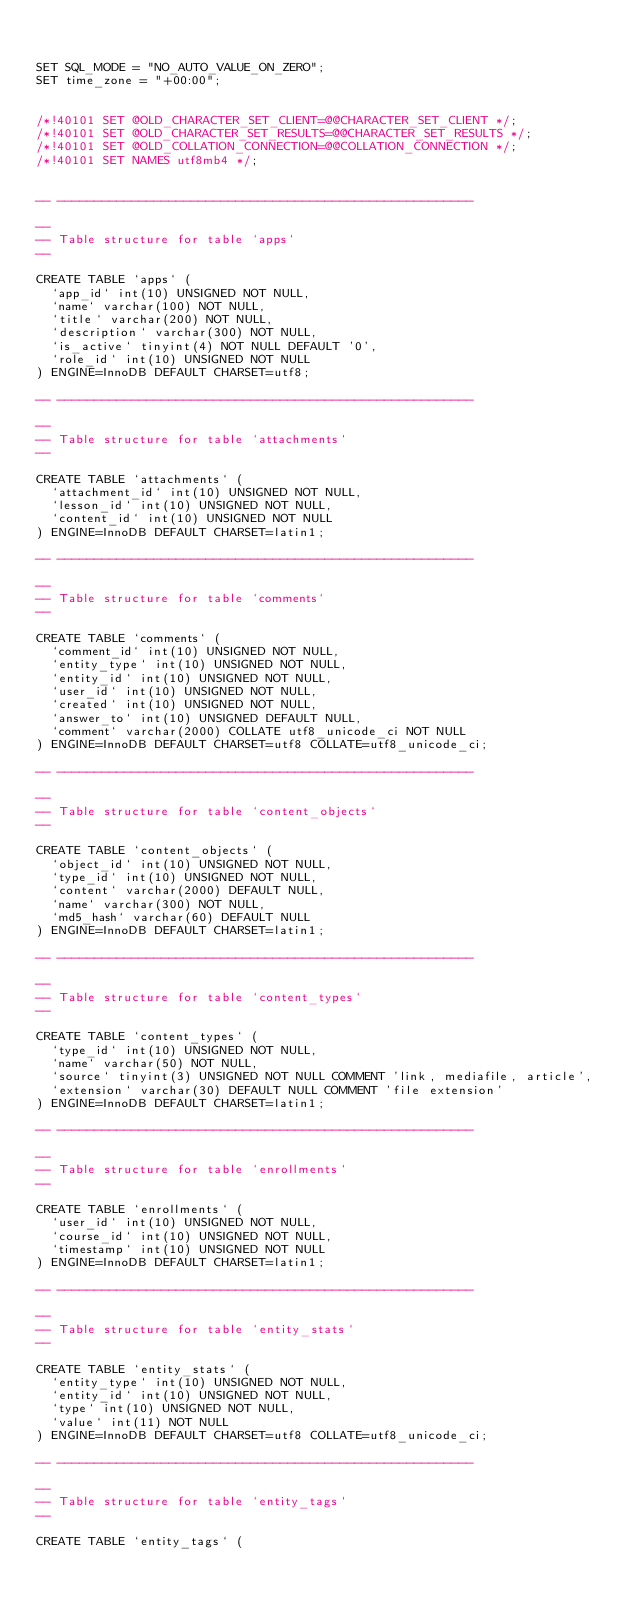Convert code to text. <code><loc_0><loc_0><loc_500><loc_500><_SQL_>

SET SQL_MODE = "NO_AUTO_VALUE_ON_ZERO";
SET time_zone = "+00:00";


/*!40101 SET @OLD_CHARACTER_SET_CLIENT=@@CHARACTER_SET_CLIENT */;
/*!40101 SET @OLD_CHARACTER_SET_RESULTS=@@CHARACTER_SET_RESULTS */;
/*!40101 SET @OLD_COLLATION_CONNECTION=@@COLLATION_CONNECTION */;
/*!40101 SET NAMES utf8mb4 */;


-- --------------------------------------------------------

--
-- Table structure for table `apps`
--

CREATE TABLE `apps` (
  `app_id` int(10) UNSIGNED NOT NULL,
  `name` varchar(100) NOT NULL,
  `title` varchar(200) NOT NULL,
  `description` varchar(300) NOT NULL,
  `is_active` tinyint(4) NOT NULL DEFAULT '0',
  `role_id` int(10) UNSIGNED NOT NULL
) ENGINE=InnoDB DEFAULT CHARSET=utf8;

-- --------------------------------------------------------

--
-- Table structure for table `attachments`
--

CREATE TABLE `attachments` (
  `attachment_id` int(10) UNSIGNED NOT NULL,
  `lesson_id` int(10) UNSIGNED NOT NULL,
  `content_id` int(10) UNSIGNED NOT NULL
) ENGINE=InnoDB DEFAULT CHARSET=latin1;

-- --------------------------------------------------------

--
-- Table structure for table `comments`
--

CREATE TABLE `comments` (
  `comment_id` int(10) UNSIGNED NOT NULL,
  `entity_type` int(10) UNSIGNED NOT NULL,
  `entity_id` int(10) UNSIGNED NOT NULL,
  `user_id` int(10) UNSIGNED NOT NULL,
  `created` int(10) UNSIGNED NOT NULL,
  `answer_to` int(10) UNSIGNED DEFAULT NULL,
  `comment` varchar(2000) COLLATE utf8_unicode_ci NOT NULL
) ENGINE=InnoDB DEFAULT CHARSET=utf8 COLLATE=utf8_unicode_ci;

-- --------------------------------------------------------

--
-- Table structure for table `content_objects`
--

CREATE TABLE `content_objects` (
  `object_id` int(10) UNSIGNED NOT NULL,
  `type_id` int(10) UNSIGNED NOT NULL,
  `content` varchar(2000) DEFAULT NULL,
  `name` varchar(300) NOT NULL,
  `md5_hash` varchar(60) DEFAULT NULL
) ENGINE=InnoDB DEFAULT CHARSET=latin1;

-- --------------------------------------------------------

--
-- Table structure for table `content_types`
--

CREATE TABLE `content_types` (
  `type_id` int(10) UNSIGNED NOT NULL,
  `name` varchar(50) NOT NULL,
  `source` tinyint(3) UNSIGNED NOT NULL COMMENT 'link, mediafile, article',
  `extension` varchar(30) DEFAULT NULL COMMENT 'file extension'
) ENGINE=InnoDB DEFAULT CHARSET=latin1;

-- --------------------------------------------------------

--
-- Table structure for table `enrollments`
--

CREATE TABLE `enrollments` (
  `user_id` int(10) UNSIGNED NOT NULL,
  `course_id` int(10) UNSIGNED NOT NULL,
  `timestamp` int(10) UNSIGNED NOT NULL
) ENGINE=InnoDB DEFAULT CHARSET=latin1;

-- --------------------------------------------------------

--
-- Table structure for table `entity_stats`
--

CREATE TABLE `entity_stats` (
  `entity_type` int(10) UNSIGNED NOT NULL,
  `entity_id` int(10) UNSIGNED NOT NULL,
  `type` int(10) UNSIGNED NOT NULL,
  `value` int(11) NOT NULL
) ENGINE=InnoDB DEFAULT CHARSET=utf8 COLLATE=utf8_unicode_ci;

-- --------------------------------------------------------

--
-- Table structure for table `entity_tags`
--

CREATE TABLE `entity_tags` (</code> 